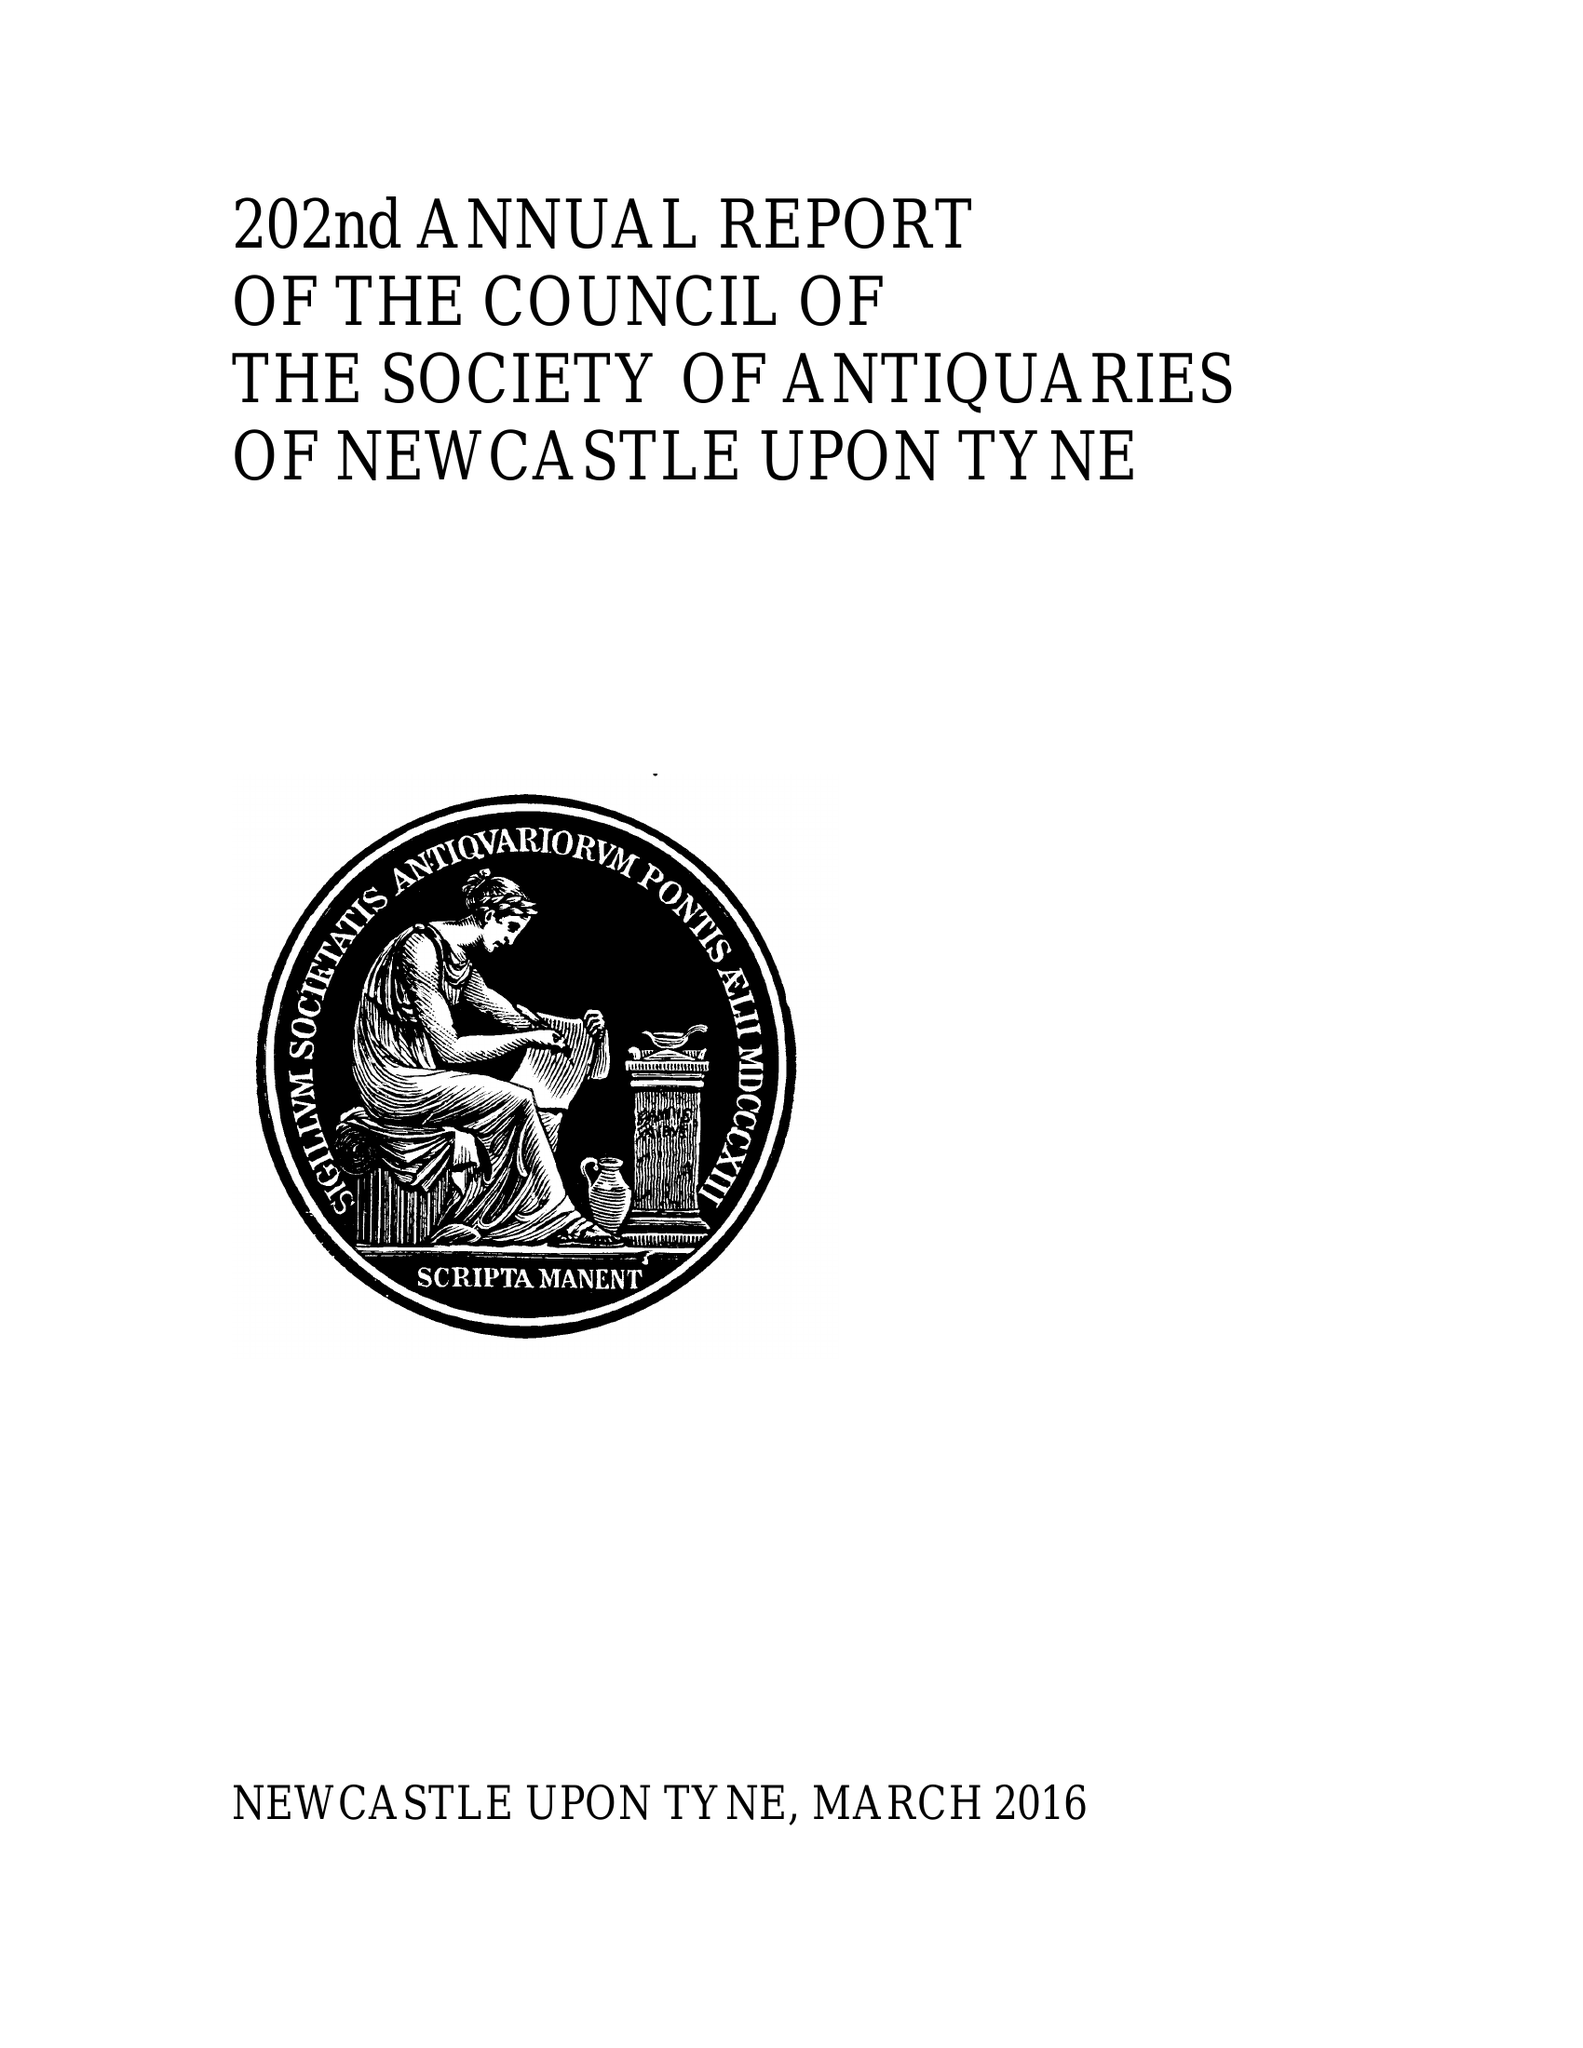What is the value for the charity_number?
Answer the question using a single word or phrase. 230888 